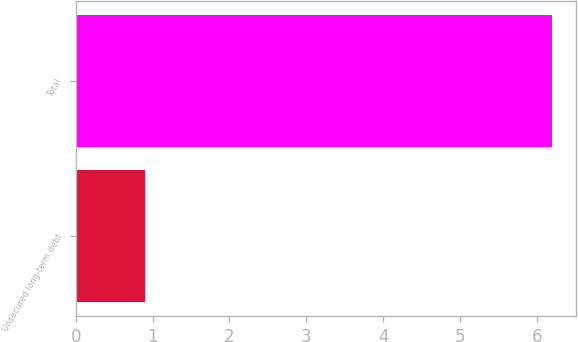Convert chart. <chart><loc_0><loc_0><loc_500><loc_500><bar_chart><fcel>Unsecured long-term debt<fcel>Total<nl><fcel>0.9<fcel>6.2<nl></chart> 